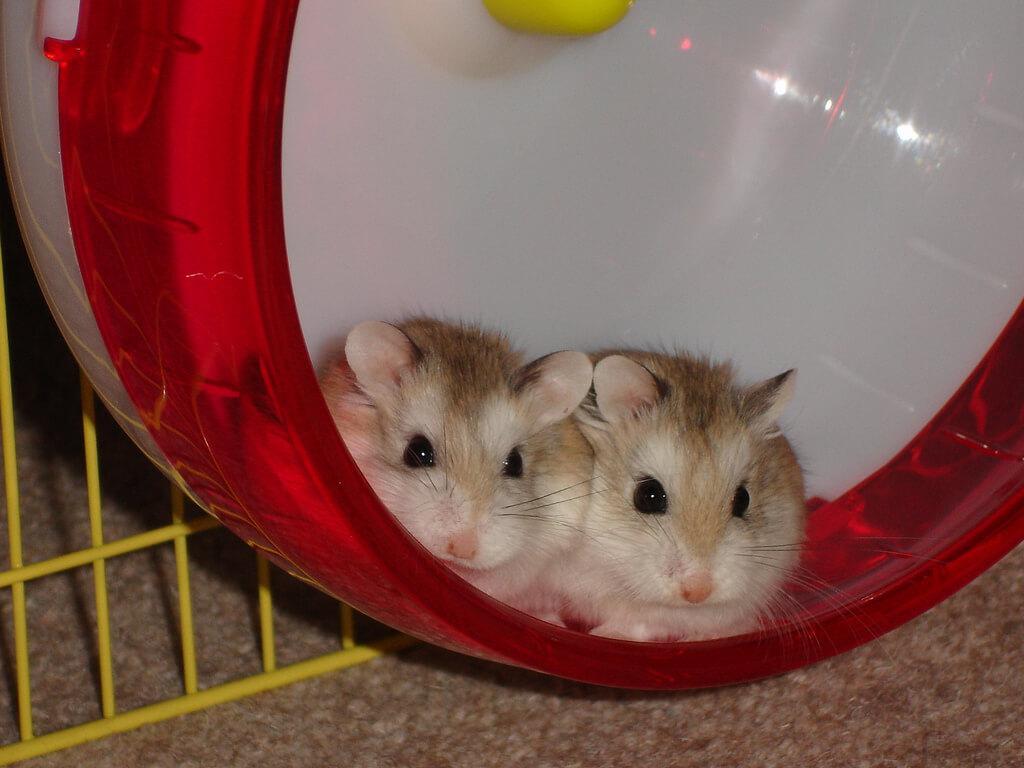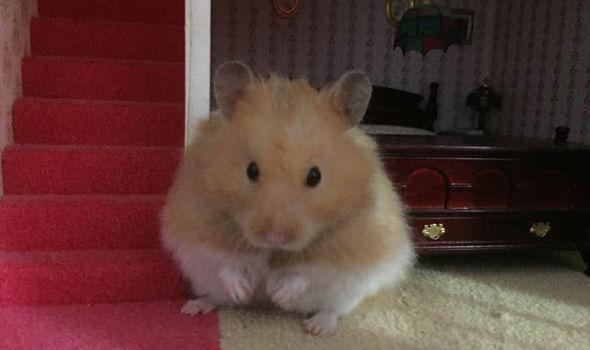The first image is the image on the left, the second image is the image on the right. Evaluate the accuracy of this statement regarding the images: "The images contain a total of four hamsters that are on a plastic object.". Is it true? Answer yes or no. No. The first image is the image on the left, the second image is the image on the right. For the images displayed, is the sentence "At least one image shows only one hamster." factually correct? Answer yes or no. Yes. 